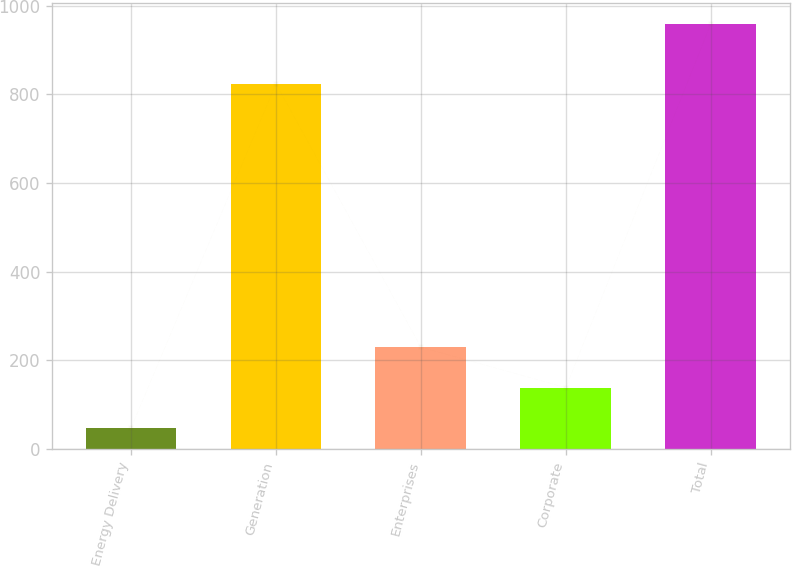<chart> <loc_0><loc_0><loc_500><loc_500><bar_chart><fcel>Energy Delivery<fcel>Generation<fcel>Enterprises<fcel>Corporate<fcel>Total<nl><fcel>47<fcel>824<fcel>229.4<fcel>138.2<fcel>959<nl></chart> 